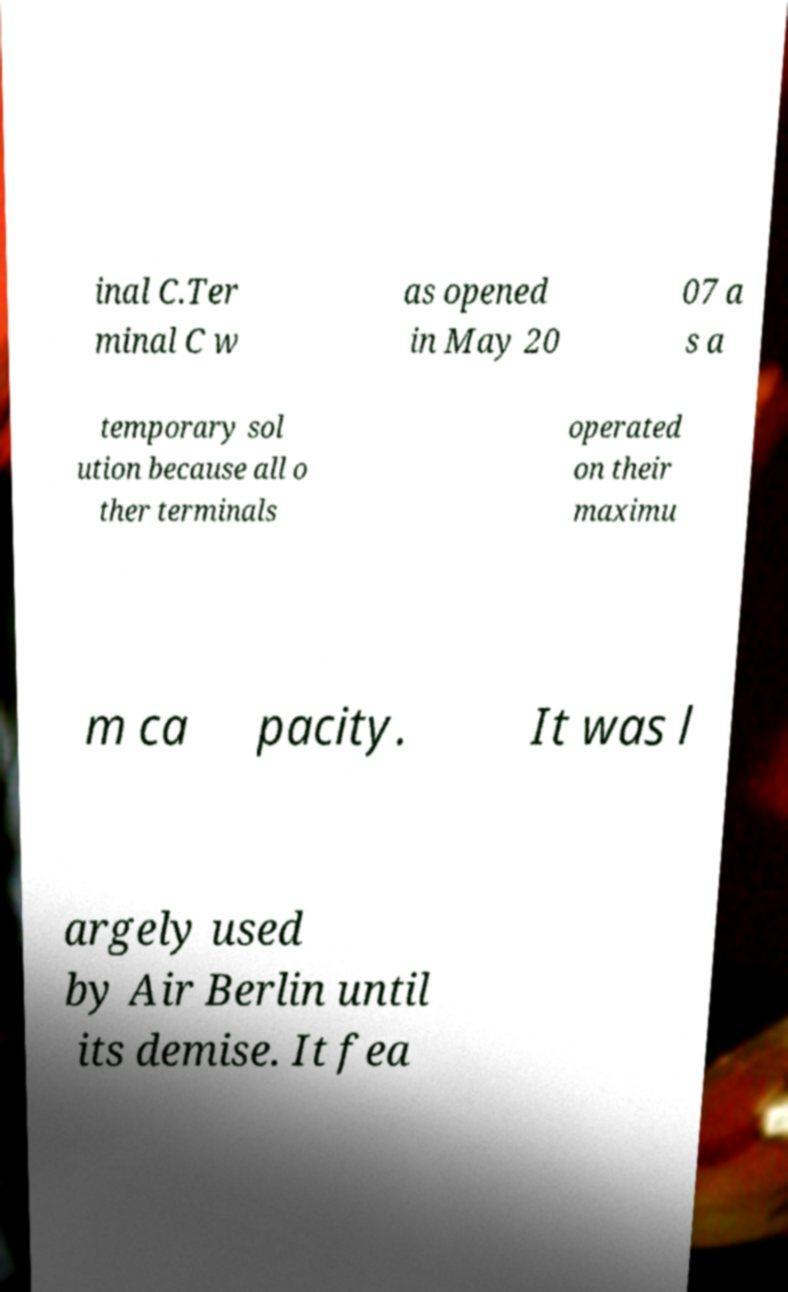Could you assist in decoding the text presented in this image and type it out clearly? inal C.Ter minal C w as opened in May 20 07 a s a temporary sol ution because all o ther terminals operated on their maximu m ca pacity. It was l argely used by Air Berlin until its demise. It fea 